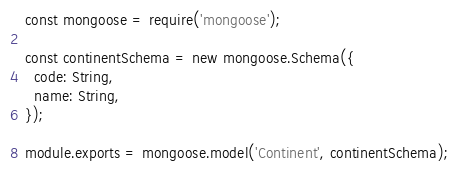<code> <loc_0><loc_0><loc_500><loc_500><_JavaScript_>const mongoose = require('mongoose');

const continentSchema = new mongoose.Schema({
  code: String,
  name: String,
});

module.exports = mongoose.model('Continent', continentSchema);
</code> 